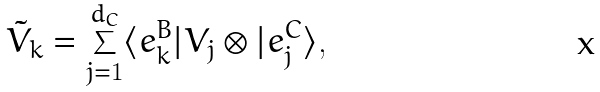<formula> <loc_0><loc_0><loc_500><loc_500>\tilde { V } _ { k } = \sum _ { j = 1 } ^ { d _ { C } } \langle e _ { k } ^ { B } | V _ { j } \otimes | e _ { j } ^ { C } \rangle ,</formula> 